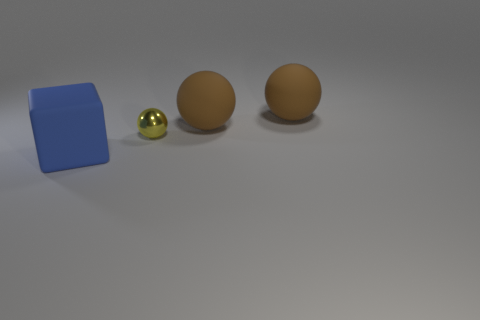Subtract all large brown matte spheres. How many spheres are left? 1 Add 2 yellow objects. How many objects exist? 6 Subtract 3 balls. How many balls are left? 0 Subtract all yellow spheres. How many spheres are left? 2 Subtract all blocks. How many objects are left? 3 Subtract all green balls. Subtract all red blocks. How many balls are left? 3 Subtract all yellow blocks. How many brown balls are left? 2 Subtract all large rubber objects. Subtract all tiny metal spheres. How many objects are left? 0 Add 1 blue rubber objects. How many blue rubber objects are left? 2 Add 4 big blocks. How many big blocks exist? 5 